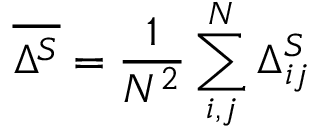<formula> <loc_0><loc_0><loc_500><loc_500>\overline { { \Delta ^ { S } } } = \frac { 1 } { N ^ { 2 } } \sum _ { i , j } ^ { N } \Delta _ { i j } ^ { S }</formula> 